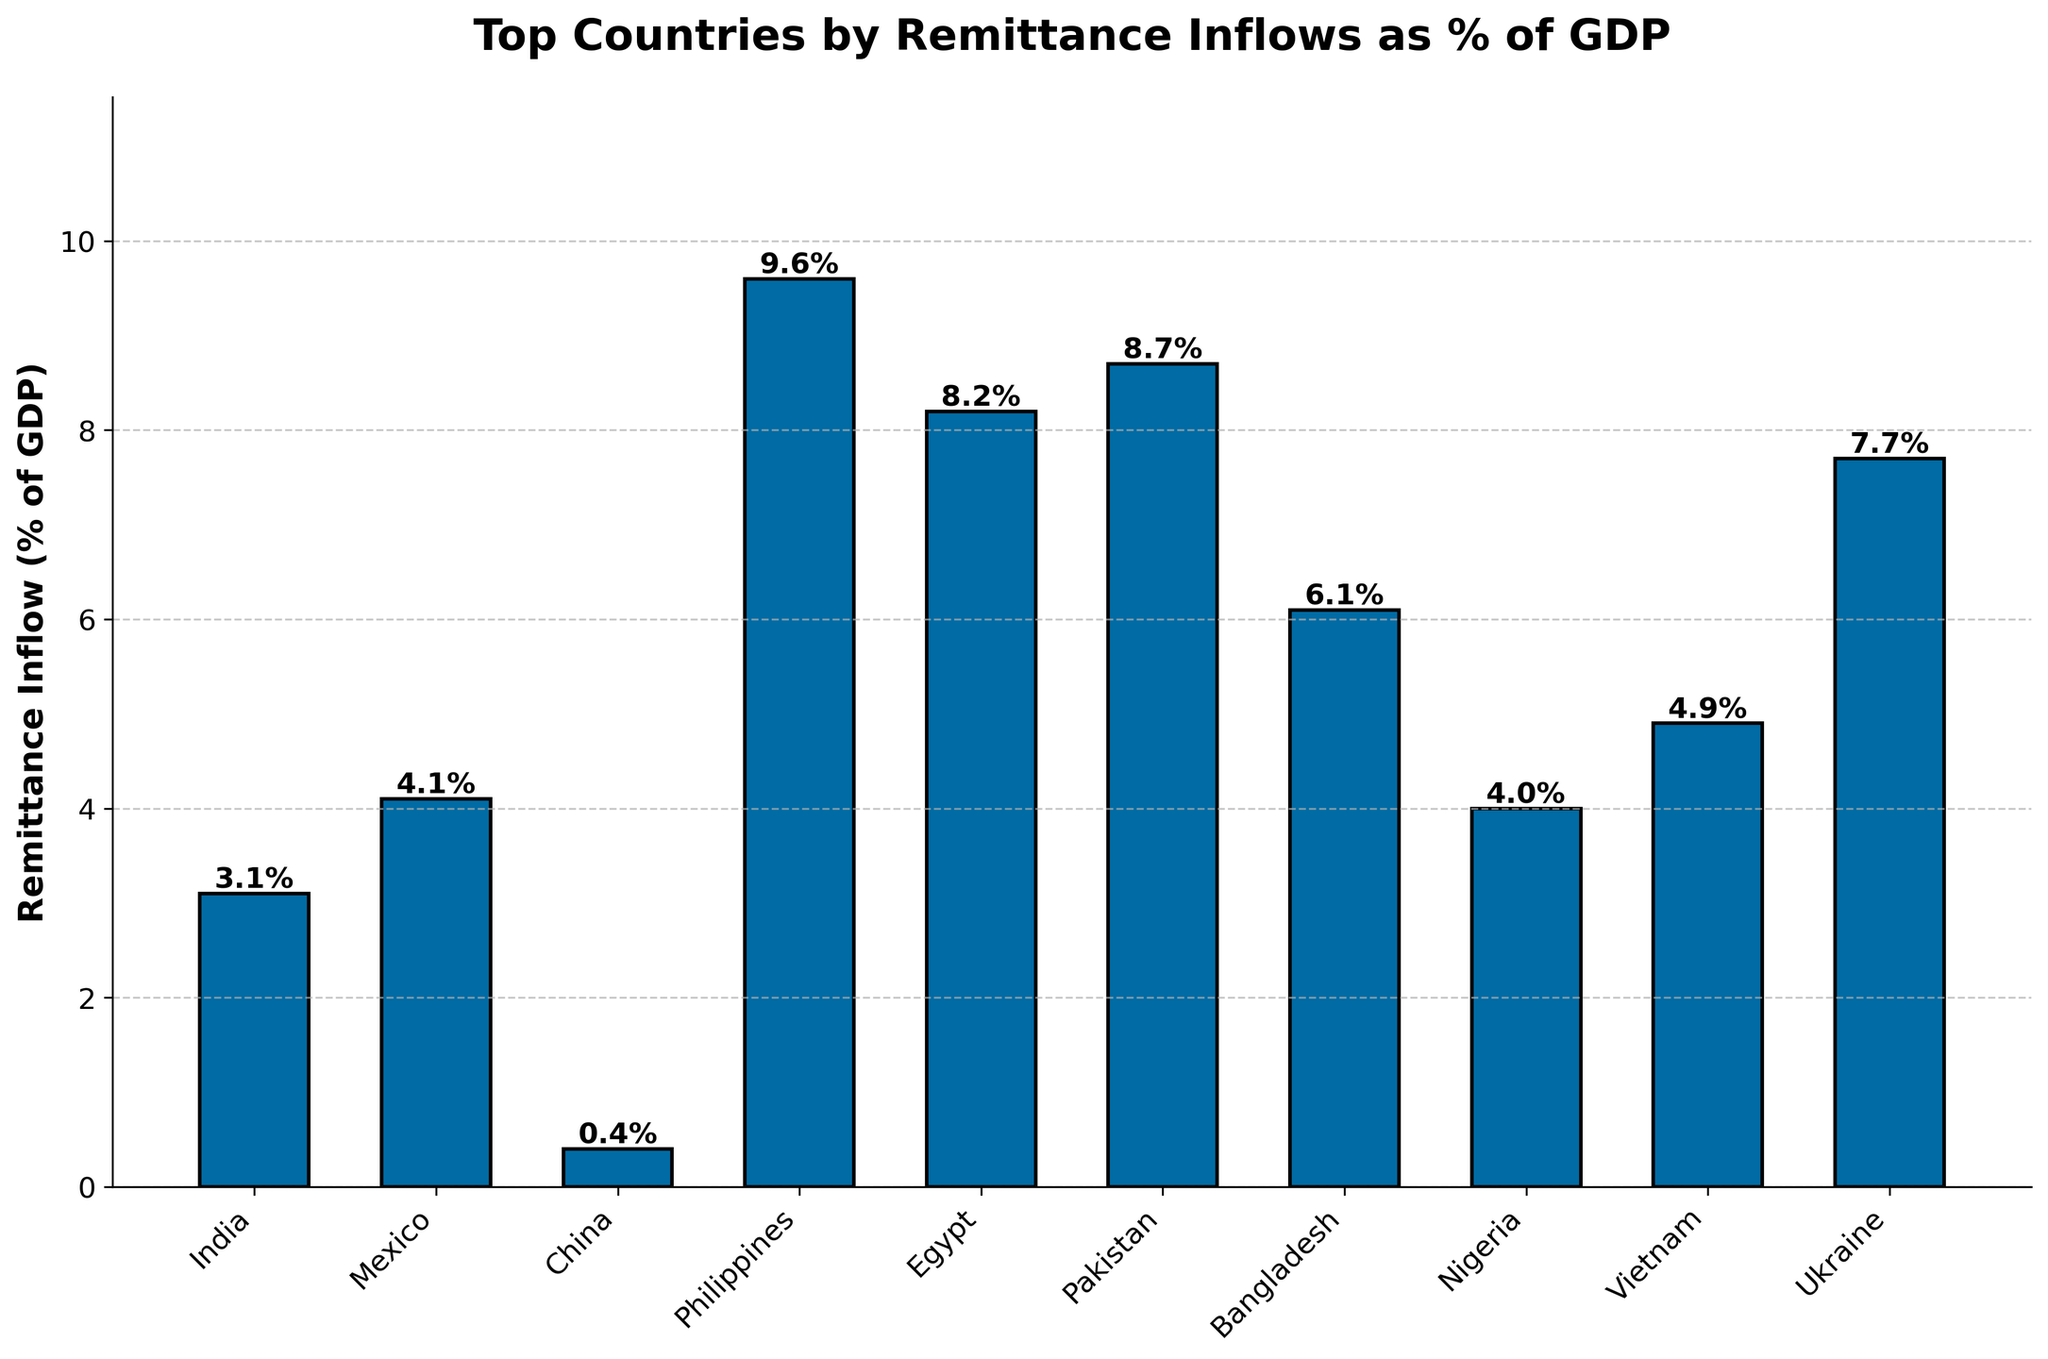Which country has the highest remittance inflow as a percentage of GDP? According to the chart, Philippines has the highest remittance inflow percentage among the listed countries.
Answer: Philippines Which country has the lowest percentage of remittance inflow in their GDP? The chart shows that China has the smallest remittance inflow percentage of GDP among the countries listed.
Answer: China What is the combined remittance inflow percentage of GDP for Egypt and Pakistan? From the chart, Egypt has 8.2% and Pakistan has 8.7%. Adding these together gives 8.2 + 8.7 = 16.9%.
Answer: 16.9% How much higher is the remittance inflow percentage of GDP for the Philippines compared to Mexico? The chart shows Philippines with 9.6% and Mexico with 4.1%. The difference is 9.6 - 4.1 = 5.5%.
Answer: 5.5% Is Nigeria's remittance inflow percentage of GDP higher or lower than Mexico's? The chart clearly shows that Nigeria has a remittance inflow of 4.0% while Mexico has 4.1%. This means Nigeria's percentage is lower than Mexico's.
Answer: Lower Rank the five countries with the highest remittance inflow percentages. From the chart, we can rank the top five countries as follows: Philippines (9.6%), Pakistan (8.7%), Egypt (8.2%), Ukraine (7.7%), Bangladesh (6.1%).
Answer: 1. Philippines, 2. Pakistan, 3. Egypt, 4. Ukraine, 5. Bangladesh If you were to average the remittance inflow percentages of Vietnam, Nigeria, and Bangladesh, what would it be? According to the chart, Vietnam has 4.9%, Nigeria has 4.0%, and Bangladesh has 6.1%. The average is (4.9 + 4.0 + 6.1) / 3 = 5%.
Answer: 5% Which country has a percentage of remittance inflow closest to Vietnam's? The chart shows Vietnam with 4.9%. Nigeria falls the closest with a percentage of 4.0%.
Answer: Nigeria 